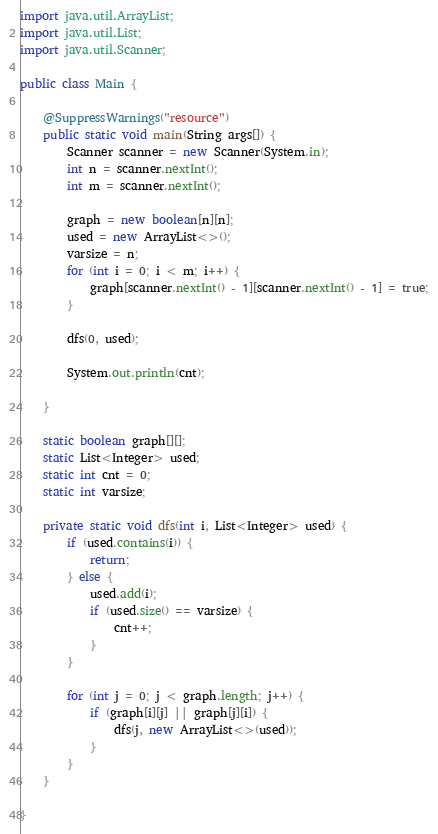Convert code to text. <code><loc_0><loc_0><loc_500><loc_500><_Java_>import java.util.ArrayList;
import java.util.List;
import java.util.Scanner;

public class Main {

	@SuppressWarnings("resource")
	public static void main(String args[]) {
		Scanner scanner = new Scanner(System.in);
		int n = scanner.nextInt();
		int m = scanner.nextInt();

		graph = new boolean[n][n];
		used = new ArrayList<>();
		varsize = n;
		for (int i = 0; i < m; i++) {
			graph[scanner.nextInt() - 1][scanner.nextInt() - 1] = true;
		}

		dfs(0, used);

		System.out.println(cnt);

	}

	static boolean graph[][];
	static List<Integer> used;
	static int cnt = 0;
	static int varsize;

	private static void dfs(int i, List<Integer> used) {
		if (used.contains(i)) {
			return;
		} else {
			used.add(i);
			if (used.size() == varsize) {
				cnt++;
			}
		}

		for (int j = 0; j < graph.length; j++) {
			if (graph[i][j] || graph[j][i]) {
				dfs(j, new ArrayList<>(used));
			}
		}
	}

}</code> 